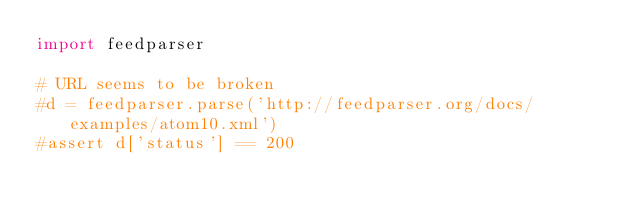<code> <loc_0><loc_0><loc_500><loc_500><_Python_>import feedparser

# URL seems to be broken
#d = feedparser.parse('http://feedparser.org/docs/examples/atom10.xml')
#assert d['status'] == 200
</code> 